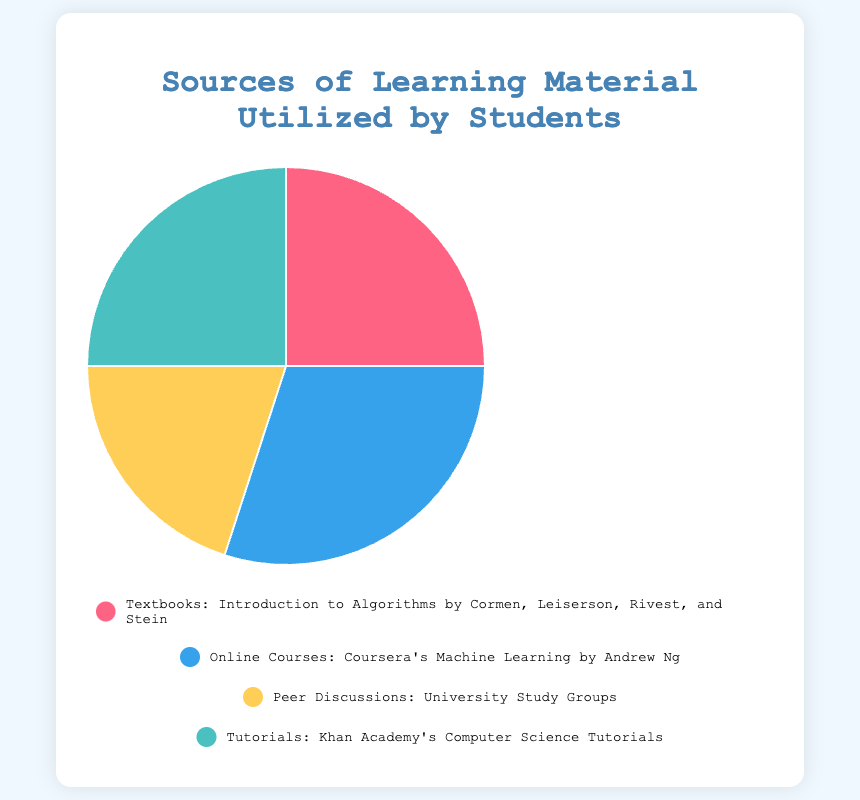What is the most utilized source of learning material by students? Look at the pie chart and determine which source occupies the largest segment. The largest segment belongs to "Online Courses."
Answer: Online Courses What combined percentage of students use Textbooks and Tutorials for learning? Add the percentages for Textbooks and Tutorials together: 25% (Textbooks) + 25% (Tutorials) = 50%.
Answer: 50% Which two sources have an equal proportion of use among students? Identify the segments with the same size on the pie chart. Both Textbooks and Tutorials occupy 25% each.
Answer: Textbooks and Tutorials How much more percentage do Online Courses provide compared to Peer Discussions? Subtract the percentage of Peer Discussions from Online Courses: 30% (Online Courses) - 20% (Peer Discussions) = 10%.
Answer: 10% What is the least utilized source of learning material by students? The smallest segment on the pie chart represents Peer Discussions, which is 20%.
Answer: Peer Discussions What is the sum of the percentages of Peer Discussions and Online Courses? Add the percentages for Peer Discussions and Online Courses: 20% (Peer Discussions) + 30% (Online Courses) = 50%.
Answer: 50% Which source represents 20% of the learning material used by students? Find the segment that occupies 20% of the pie chart. Peer Discussions represents 20%.
Answer: Peer Discussions What percentage difference between the largest and smallest source of learning materials? Identify the largest and smallest percentages and subtract them: 30% (largest, Online Courses) - 20% (smallest, Peer Discussions) = 10%.
Answer: 10% How many sources of learning material each make up exactly a quarter of the chart? Identify the sources that constitute exactly 25% of the pie chart. Both Textbooks and Tutorials make up 25% each. There are 2 such sources.
Answer: 2 